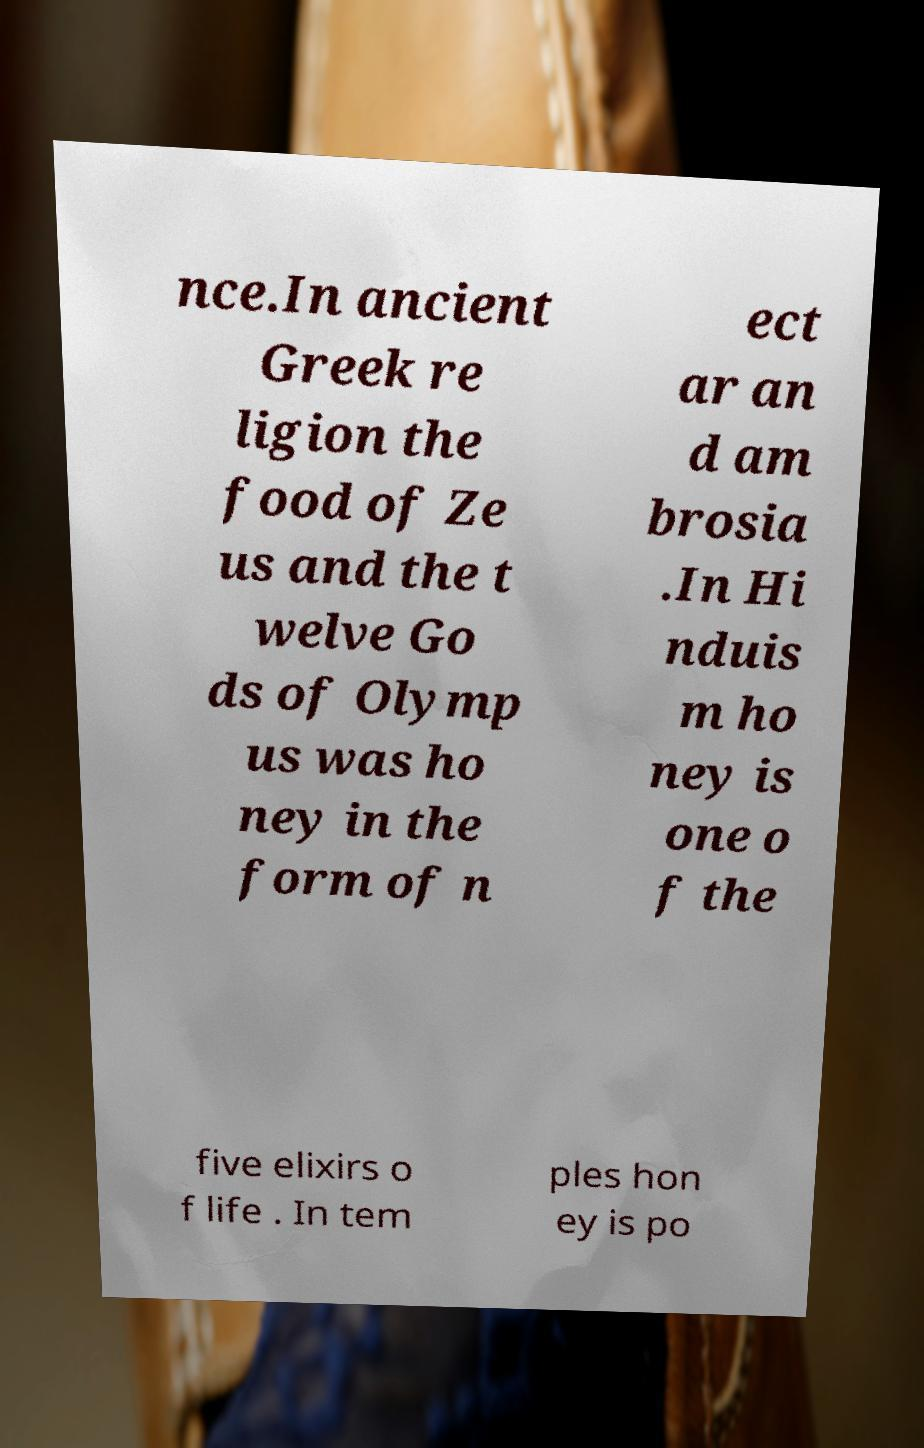Can you read and provide the text displayed in the image?This photo seems to have some interesting text. Can you extract and type it out for me? nce.In ancient Greek re ligion the food of Ze us and the t welve Go ds of Olymp us was ho ney in the form of n ect ar an d am brosia .In Hi nduis m ho ney is one o f the five elixirs o f life . In tem ples hon ey is po 